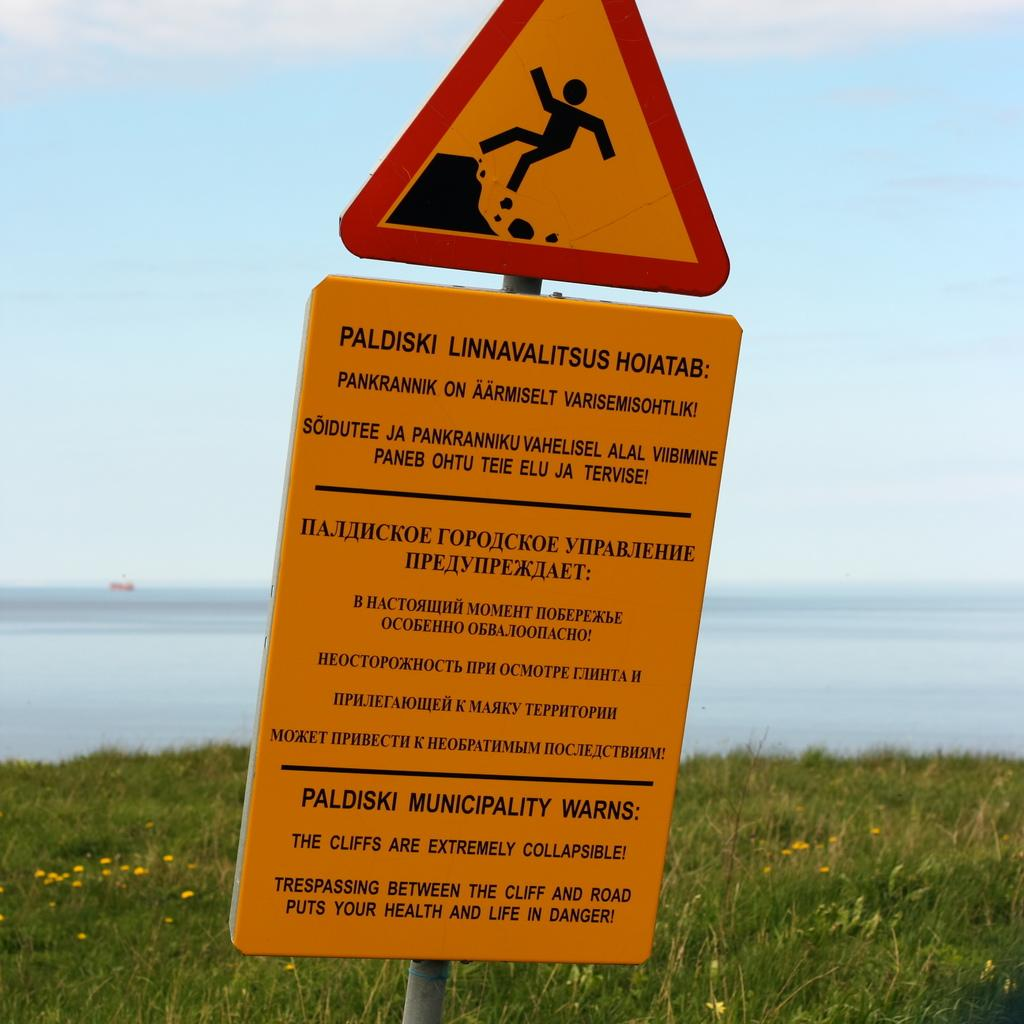<image>
Provide a brief description of the given image. A yellow warning sign that has been installed by the Paldiski Municipality. 